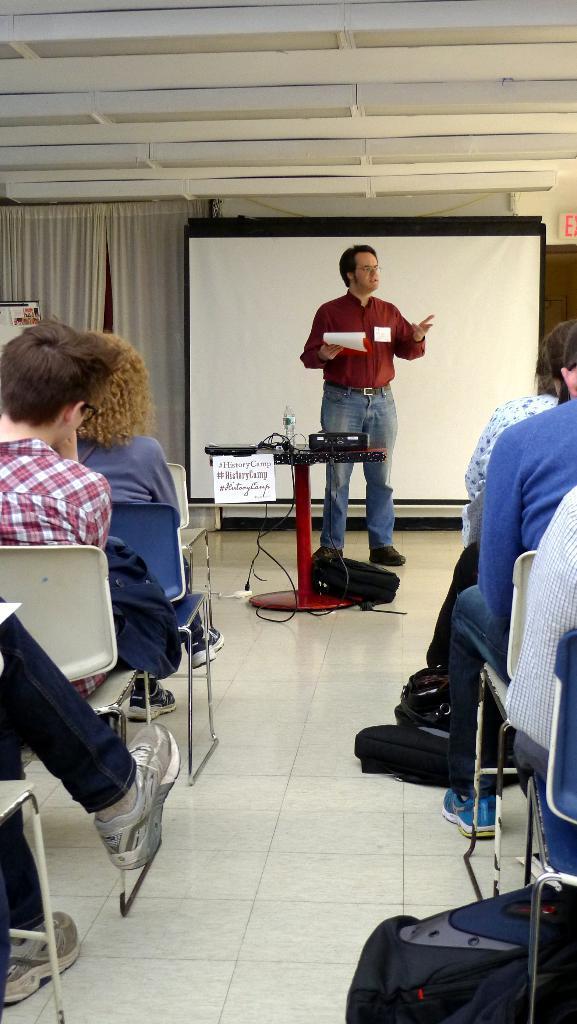Please provide a concise description of this image. On either side of the picture, we see people are sitting on the chairs. In the right bottom, we see a bag. At the bottom, we see the floor. In the middle of the picture, we see a table on which the projector, cables and a water bottle are placed. We see a white board with some text written on it. We see a black bag under the table. Behind that, we see a man is standing. He is holding the papers and he is explaining something. Behind him, we see the projector screen. In the background, we see a wall and the white curtains. At the top, we see the ceiling of the room. 